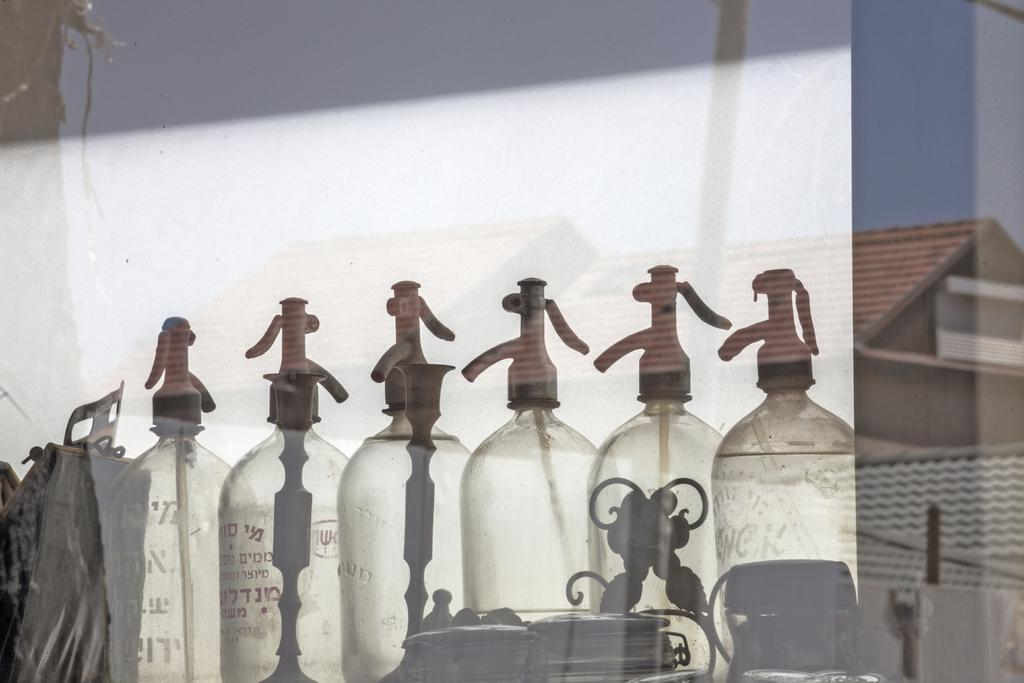What objects can be seen in the image? There are flasks in the image. What type of structure is visible in the image? There is a house in the image. What type of shade is provided by the flasks in the image? There is no shade provided by the flasks in the image, as they are objects and not structures. 